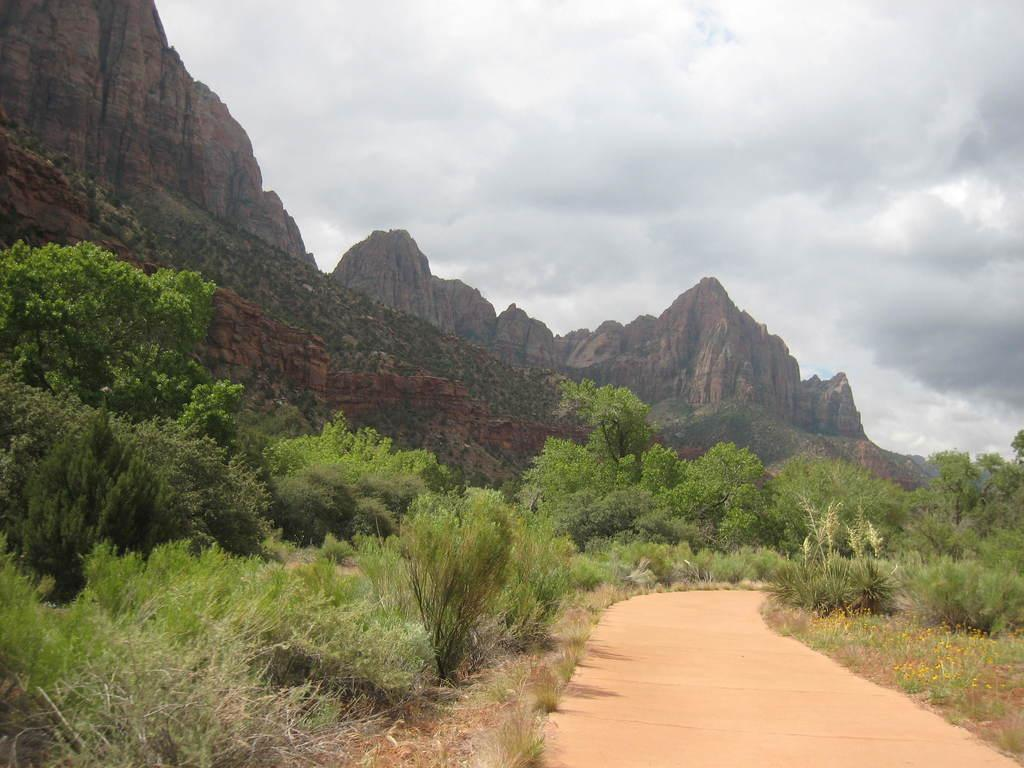What is the main feature of the image? There is a road in the image. What can be seen on both sides of the road? Grass and trees are present on both sides of the road. What is visible in the background of the image? Trees, mountains, clouds, and the sky are visible in the background of the image. What type of wine is being served in the morning in the image? There is no wine or morning scene present in the image; it features a road with grass, trees, and a background with mountains, clouds, and the sky. 